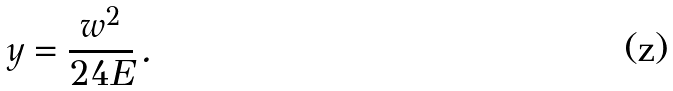Convert formula to latex. <formula><loc_0><loc_0><loc_500><loc_500>y = \frac { w ^ { 2 } } { 2 4 E } \, .</formula> 